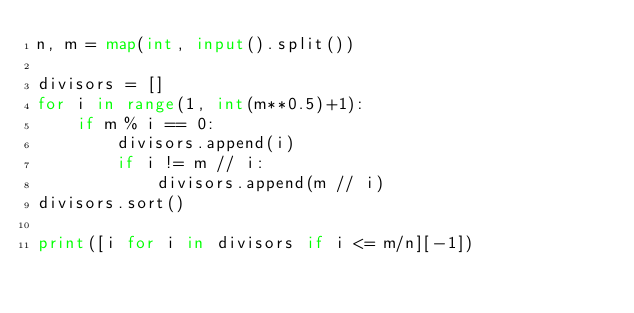Convert code to text. <code><loc_0><loc_0><loc_500><loc_500><_Python_>n, m = map(int, input().split())

divisors = []
for i in range(1, int(m**0.5)+1):
    if m % i == 0:
        divisors.append(i)
        if i != m // i:
            divisors.append(m // i)
divisors.sort()

print([i for i in divisors if i <= m/n][-1])
</code> 